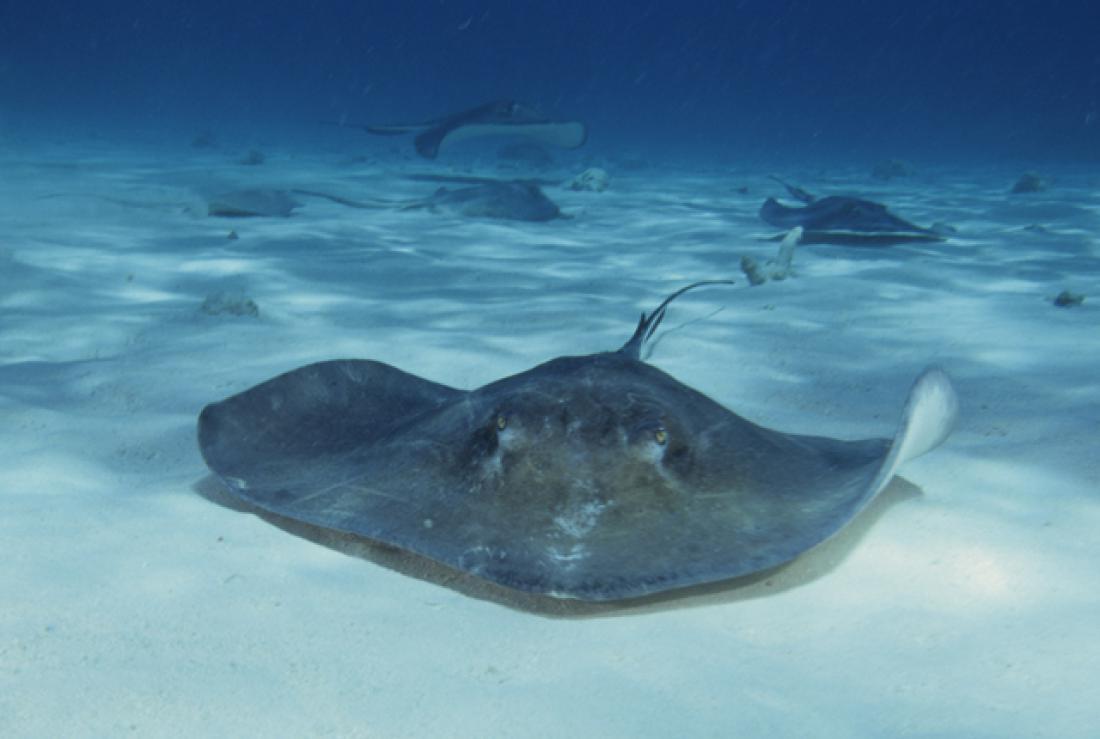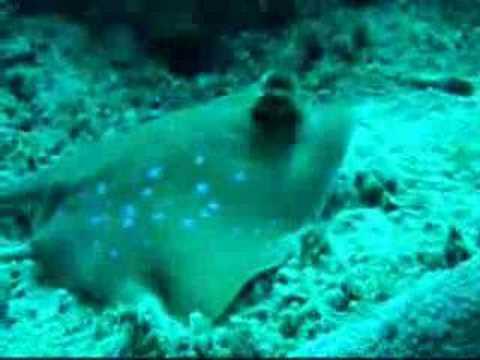The first image is the image on the left, the second image is the image on the right. For the images shown, is this caption "There are more rays in the image on the left than in the image on the right." true? Answer yes or no. Yes. The first image is the image on the left, the second image is the image on the right. Examine the images to the left and right. Is the description "Both images include a stingray at the bottom of the ocean." accurate? Answer yes or no. Yes. 